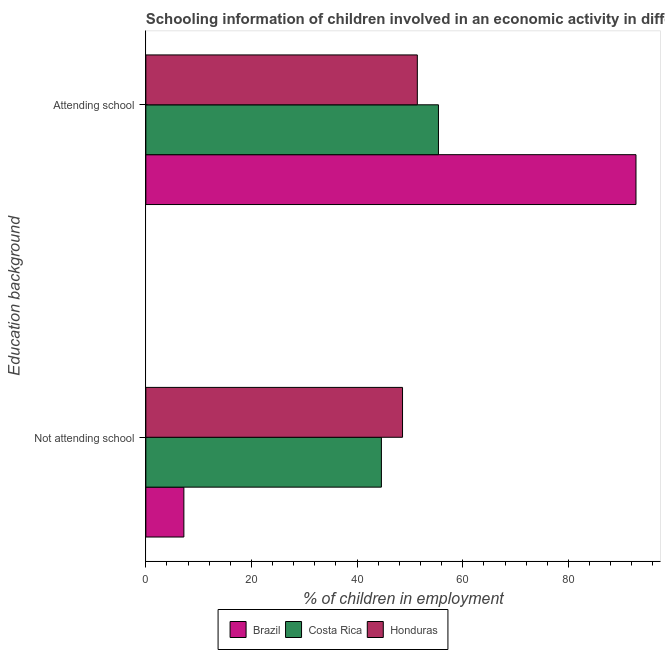Are the number of bars per tick equal to the number of legend labels?
Your answer should be compact. Yes. Are the number of bars on each tick of the Y-axis equal?
Offer a very short reply. Yes. How many bars are there on the 2nd tick from the bottom?
Offer a terse response. 3. What is the label of the 1st group of bars from the top?
Your answer should be compact. Attending school. What is the percentage of employed children who are not attending school in Honduras?
Make the answer very short. 48.6. Across all countries, what is the maximum percentage of employed children who are not attending school?
Ensure brevity in your answer.  48.6. Across all countries, what is the minimum percentage of employed children who are attending school?
Make the answer very short. 51.4. In which country was the percentage of employed children who are not attending school maximum?
Your response must be concise. Honduras. In which country was the percentage of employed children who are not attending school minimum?
Provide a short and direct response. Brazil. What is the total percentage of employed children who are attending school in the graph?
Your answer should be very brief. 199.6. What is the difference between the percentage of employed children who are attending school in Brazil and that in Honduras?
Provide a succinct answer. 41.4. What is the difference between the percentage of employed children who are not attending school in Brazil and the percentage of employed children who are attending school in Costa Rica?
Make the answer very short. -48.2. What is the average percentage of employed children who are not attending school per country?
Offer a very short reply. 33.47. What is the difference between the percentage of employed children who are not attending school and percentage of employed children who are attending school in Honduras?
Make the answer very short. -2.8. In how many countries, is the percentage of employed children who are attending school greater than 16 %?
Offer a terse response. 3. What is the ratio of the percentage of employed children who are attending school in Brazil to that in Costa Rica?
Make the answer very short. 1.68. Is the percentage of employed children who are not attending school in Costa Rica less than that in Brazil?
Give a very brief answer. No. What does the 1st bar from the top in Not attending school represents?
Provide a succinct answer. Honduras. What does the 1st bar from the bottom in Attending school represents?
Offer a terse response. Brazil. How many countries are there in the graph?
Ensure brevity in your answer.  3. What is the difference between two consecutive major ticks on the X-axis?
Ensure brevity in your answer.  20. Are the values on the major ticks of X-axis written in scientific E-notation?
Your response must be concise. No. Does the graph contain any zero values?
Make the answer very short. No. How are the legend labels stacked?
Give a very brief answer. Horizontal. What is the title of the graph?
Offer a terse response. Schooling information of children involved in an economic activity in different countries. Does "Denmark" appear as one of the legend labels in the graph?
Your answer should be very brief. No. What is the label or title of the X-axis?
Give a very brief answer. % of children in employment. What is the label or title of the Y-axis?
Offer a very short reply. Education background. What is the % of children in employment in Costa Rica in Not attending school?
Offer a terse response. 44.6. What is the % of children in employment of Honduras in Not attending school?
Provide a succinct answer. 48.6. What is the % of children in employment in Brazil in Attending school?
Keep it short and to the point. 92.8. What is the % of children in employment in Costa Rica in Attending school?
Keep it short and to the point. 55.4. What is the % of children in employment of Honduras in Attending school?
Offer a terse response. 51.4. Across all Education background, what is the maximum % of children in employment of Brazil?
Your answer should be compact. 92.8. Across all Education background, what is the maximum % of children in employment in Costa Rica?
Keep it short and to the point. 55.4. Across all Education background, what is the maximum % of children in employment in Honduras?
Provide a succinct answer. 51.4. Across all Education background, what is the minimum % of children in employment in Costa Rica?
Provide a short and direct response. 44.6. Across all Education background, what is the minimum % of children in employment of Honduras?
Your answer should be very brief. 48.6. What is the total % of children in employment of Brazil in the graph?
Give a very brief answer. 100. What is the total % of children in employment in Honduras in the graph?
Your answer should be compact. 100. What is the difference between the % of children in employment of Brazil in Not attending school and that in Attending school?
Your response must be concise. -85.6. What is the difference between the % of children in employment in Brazil in Not attending school and the % of children in employment in Costa Rica in Attending school?
Ensure brevity in your answer.  -48.2. What is the difference between the % of children in employment in Brazil in Not attending school and the % of children in employment in Honduras in Attending school?
Ensure brevity in your answer.  -44.2. What is the average % of children in employment in Brazil per Education background?
Offer a very short reply. 50. What is the average % of children in employment in Honduras per Education background?
Your response must be concise. 50. What is the difference between the % of children in employment in Brazil and % of children in employment in Costa Rica in Not attending school?
Make the answer very short. -37.4. What is the difference between the % of children in employment of Brazil and % of children in employment of Honduras in Not attending school?
Give a very brief answer. -41.4. What is the difference between the % of children in employment of Brazil and % of children in employment of Costa Rica in Attending school?
Offer a very short reply. 37.4. What is the difference between the % of children in employment in Brazil and % of children in employment in Honduras in Attending school?
Keep it short and to the point. 41.4. What is the ratio of the % of children in employment in Brazil in Not attending school to that in Attending school?
Offer a terse response. 0.08. What is the ratio of the % of children in employment in Costa Rica in Not attending school to that in Attending school?
Your answer should be very brief. 0.81. What is the ratio of the % of children in employment of Honduras in Not attending school to that in Attending school?
Offer a very short reply. 0.95. What is the difference between the highest and the second highest % of children in employment of Brazil?
Provide a succinct answer. 85.6. What is the difference between the highest and the second highest % of children in employment in Costa Rica?
Keep it short and to the point. 10.8. What is the difference between the highest and the lowest % of children in employment of Brazil?
Give a very brief answer. 85.6. What is the difference between the highest and the lowest % of children in employment in Honduras?
Make the answer very short. 2.8. 